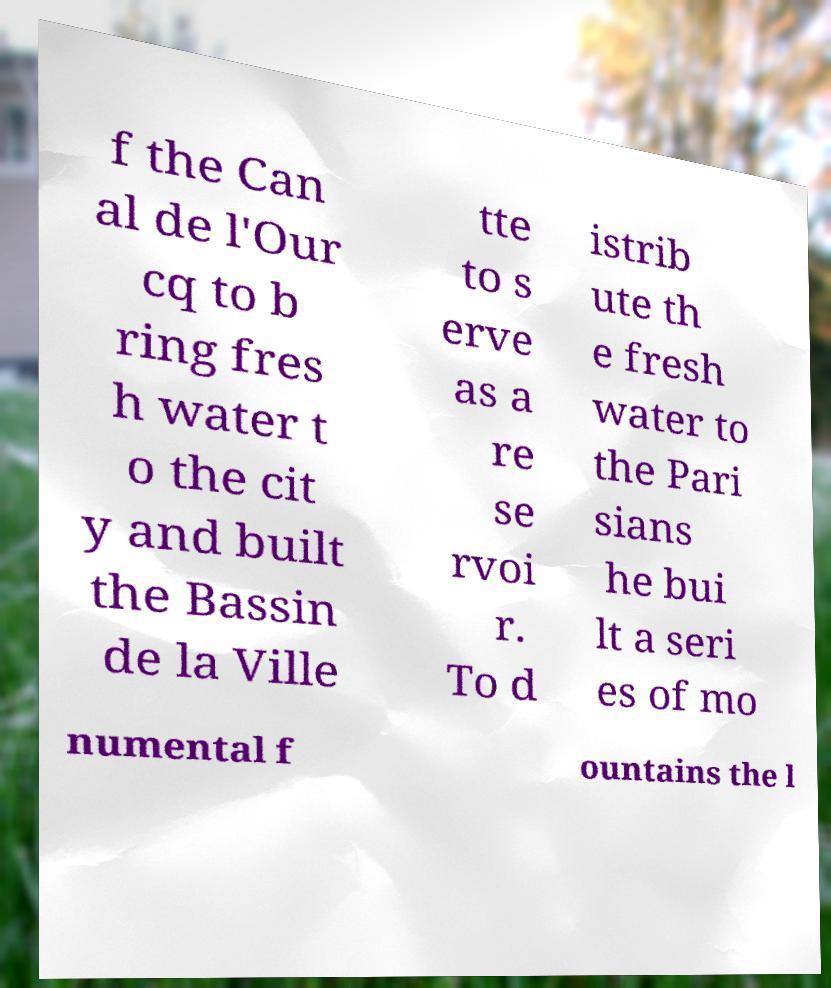Could you extract and type out the text from this image? f the Can al de l'Our cq to b ring fres h water t o the cit y and built the Bassin de la Ville tte to s erve as a re se rvoi r. To d istrib ute th e fresh water to the Pari sians he bui lt a seri es of mo numental f ountains the l 